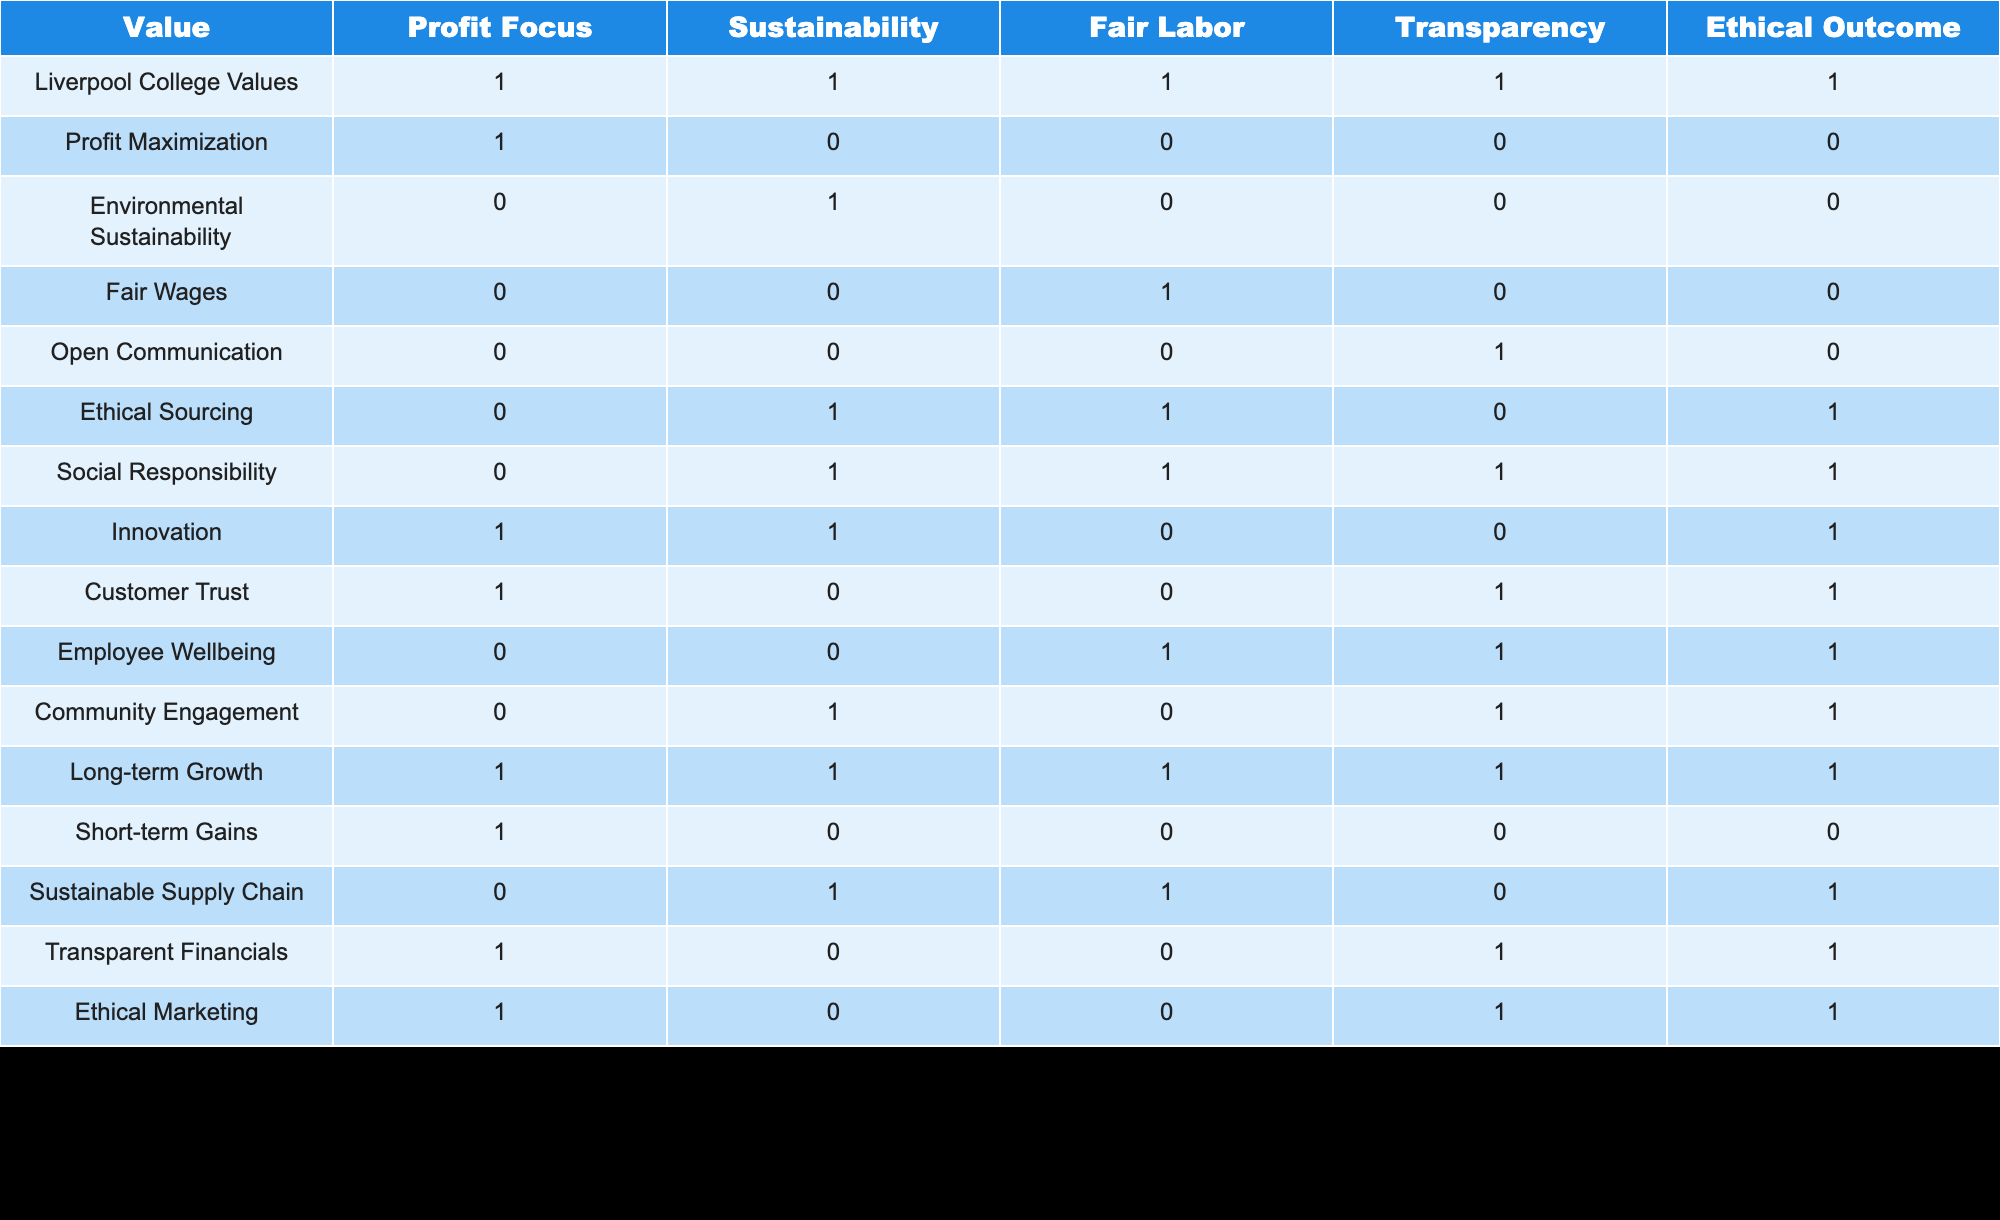What is the value assigned to Fair Labor under Liverpool College Values? Looking at the table, under the row for Liverpool College Values, the Fair Labor column has a value of 1.
Answer: 1 How many values have a focus on Sustainability? Counting the rows marked with a value of 1 in the Sustainability column gives us five values: Liverpool College Values, Environmental Sustainability, Ethical Sourcing, Social Responsibility, and Sustainable Supply Chain. Therefore, the total is 5.
Answer: 5 Does the value "Community Engagement" lead to an Ethical Outcome? Checking the Ethical Outcome column for the Community Engagement row shows a value of 1, indicating that it does lead to an Ethical Outcome.
Answer: Yes What is the total number of values that focus on both Profit and Sustainability? Examining the Profit Focus and Sustainability columns, the rows that contain a value of 1 in both are: Liverpool College Values and Innovation. Thus, there are 2 values that focus on both Profit and Sustainability.
Answer: 2 Is there any value that focuses on Ethical Sourcing but not on Sustainability? Looking at the Ethical Sourcing row, it shows a value of 1, while the Sustainability column for the same value shows 1 as well. So, there are no values that focus on Ethical Sourcing but not on Sustainability.
Answer: No Which value(s) exhibit both Transparency and an Ethical Outcome? Scanning the table, the values that have a 1 in both Transparency and Ethical Outcome columns are: Liverpool College Values, Customer Trust, Transparent Financials, and Ethical Marketing.
Answer: Liverpool College Values, Customer Trust, Transparent Financials, Ethical Marketing What is the average of the values for Ethical Outcome across all categories? Summing the values in the Ethical Outcome column gives us 8 (1 for Liverpool College Values, 0 for Profit Maximization, 0 for Environmental Sustainability, etc. up to 1 for Ethical Marketing), and since there are 14 categories, the average is 8 divided by 14 which equals approximately 0.57.
Answer: 0.57 How many values have a focus on both Employee Well-being and Transparency? Checking the Employee Well-being row, it shows 1 for Transparency in the same row, while the other value in Employee Well-being is 0. Therefore, there's a total of 1 value that meets these two criteria.
Answer: 1 Which value has the highest combination of Profit Focus and Ethical Outcome? Reviewing the Profit Focus and Ethical Outcome columns, rows for Liverpool College Values, Innovation, and Ethical Marketing all show 1 for both columns. Thus, they share the highest combination.
Answer: Liverpool College Values, Innovation, Ethical Marketing 